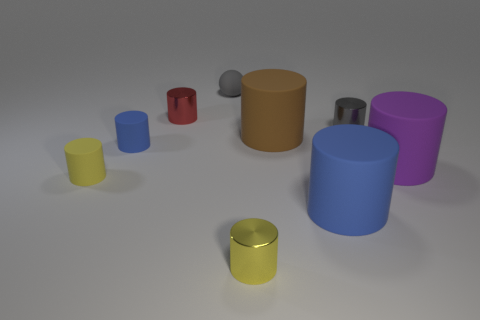Subtract all brown cylinders. How many cylinders are left? 7 Subtract all purple cylinders. How many cylinders are left? 7 Subtract all gray cylinders. Subtract all blue spheres. How many cylinders are left? 7 Subtract all cylinders. How many objects are left? 1 Subtract 0 cyan cubes. How many objects are left? 9 Subtract all gray rubber cubes. Subtract all brown matte cylinders. How many objects are left? 8 Add 5 large blue cylinders. How many large blue cylinders are left? 6 Add 6 large yellow balls. How many large yellow balls exist? 6 